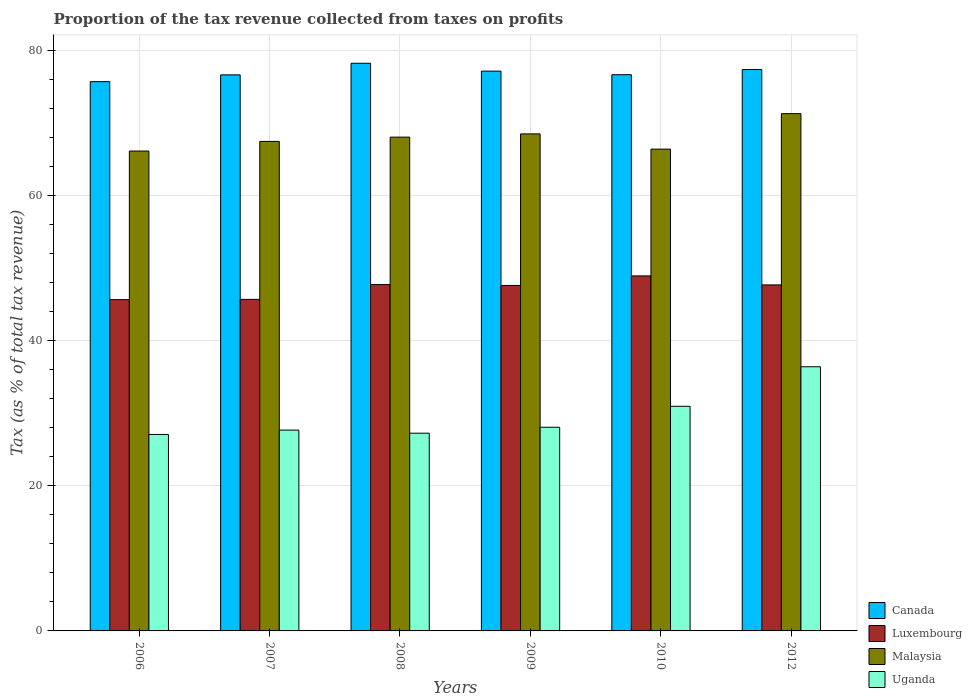How many different coloured bars are there?
Provide a succinct answer. 4. Are the number of bars per tick equal to the number of legend labels?
Your answer should be very brief. Yes. How many bars are there on the 3rd tick from the left?
Make the answer very short. 4. How many bars are there on the 4th tick from the right?
Make the answer very short. 4. In how many cases, is the number of bars for a given year not equal to the number of legend labels?
Provide a short and direct response. 0. What is the proportion of the tax revenue collected in Luxembourg in 2006?
Make the answer very short. 45.7. Across all years, what is the maximum proportion of the tax revenue collected in Canada?
Your answer should be very brief. 78.3. Across all years, what is the minimum proportion of the tax revenue collected in Canada?
Make the answer very short. 75.77. In which year was the proportion of the tax revenue collected in Luxembourg minimum?
Your response must be concise. 2006. What is the total proportion of the tax revenue collected in Malaysia in the graph?
Give a very brief answer. 408.21. What is the difference between the proportion of the tax revenue collected in Canada in 2007 and that in 2012?
Keep it short and to the point. -0.74. What is the difference between the proportion of the tax revenue collected in Uganda in 2007 and the proportion of the tax revenue collected in Canada in 2006?
Keep it short and to the point. -48.07. What is the average proportion of the tax revenue collected in Luxembourg per year?
Your response must be concise. 47.26. In the year 2009, what is the difference between the proportion of the tax revenue collected in Malaysia and proportion of the tax revenue collected in Uganda?
Your response must be concise. 40.47. What is the ratio of the proportion of the tax revenue collected in Luxembourg in 2008 to that in 2012?
Provide a short and direct response. 1. Is the proportion of the tax revenue collected in Canada in 2008 less than that in 2009?
Provide a short and direct response. No. Is the difference between the proportion of the tax revenue collected in Malaysia in 2007 and 2010 greater than the difference between the proportion of the tax revenue collected in Uganda in 2007 and 2010?
Provide a short and direct response. Yes. What is the difference between the highest and the second highest proportion of the tax revenue collected in Uganda?
Offer a very short reply. 5.46. What is the difference between the highest and the lowest proportion of the tax revenue collected in Canada?
Make the answer very short. 2.54. In how many years, is the proportion of the tax revenue collected in Uganda greater than the average proportion of the tax revenue collected in Uganda taken over all years?
Offer a terse response. 2. Is the sum of the proportion of the tax revenue collected in Canada in 2009 and 2010 greater than the maximum proportion of the tax revenue collected in Malaysia across all years?
Your answer should be very brief. Yes. What does the 2nd bar from the left in 2007 represents?
Provide a succinct answer. Luxembourg. Is it the case that in every year, the sum of the proportion of the tax revenue collected in Canada and proportion of the tax revenue collected in Luxembourg is greater than the proportion of the tax revenue collected in Malaysia?
Offer a terse response. Yes. Are all the bars in the graph horizontal?
Your answer should be very brief. No. How many legend labels are there?
Ensure brevity in your answer.  4. How are the legend labels stacked?
Give a very brief answer. Vertical. What is the title of the graph?
Your answer should be very brief. Proportion of the tax revenue collected from taxes on profits. What is the label or title of the Y-axis?
Offer a very short reply. Tax (as % of total tax revenue). What is the Tax (as % of total tax revenue) in Canada in 2006?
Ensure brevity in your answer.  75.77. What is the Tax (as % of total tax revenue) of Luxembourg in 2006?
Make the answer very short. 45.7. What is the Tax (as % of total tax revenue) in Malaysia in 2006?
Your answer should be very brief. 66.2. What is the Tax (as % of total tax revenue) in Uganda in 2006?
Your answer should be very brief. 27.1. What is the Tax (as % of total tax revenue) of Canada in 2007?
Offer a very short reply. 76.7. What is the Tax (as % of total tax revenue) in Luxembourg in 2007?
Your answer should be very brief. 45.74. What is the Tax (as % of total tax revenue) of Malaysia in 2007?
Make the answer very short. 67.53. What is the Tax (as % of total tax revenue) of Uganda in 2007?
Provide a succinct answer. 27.7. What is the Tax (as % of total tax revenue) in Canada in 2008?
Your response must be concise. 78.3. What is the Tax (as % of total tax revenue) of Luxembourg in 2008?
Provide a short and direct response. 47.78. What is the Tax (as % of total tax revenue) in Malaysia in 2008?
Your response must be concise. 68.11. What is the Tax (as % of total tax revenue) of Uganda in 2008?
Your answer should be very brief. 27.27. What is the Tax (as % of total tax revenue) in Canada in 2009?
Provide a short and direct response. 77.22. What is the Tax (as % of total tax revenue) in Luxembourg in 2009?
Your answer should be very brief. 47.66. What is the Tax (as % of total tax revenue) in Malaysia in 2009?
Offer a terse response. 68.56. What is the Tax (as % of total tax revenue) in Uganda in 2009?
Make the answer very short. 28.09. What is the Tax (as % of total tax revenue) in Canada in 2010?
Your response must be concise. 76.72. What is the Tax (as % of total tax revenue) of Luxembourg in 2010?
Provide a succinct answer. 48.97. What is the Tax (as % of total tax revenue) of Malaysia in 2010?
Your response must be concise. 66.46. What is the Tax (as % of total tax revenue) in Uganda in 2010?
Your answer should be very brief. 30.98. What is the Tax (as % of total tax revenue) of Canada in 2012?
Keep it short and to the point. 77.44. What is the Tax (as % of total tax revenue) in Luxembourg in 2012?
Provide a succinct answer. 47.73. What is the Tax (as % of total tax revenue) of Malaysia in 2012?
Ensure brevity in your answer.  71.35. What is the Tax (as % of total tax revenue) in Uganda in 2012?
Make the answer very short. 36.44. Across all years, what is the maximum Tax (as % of total tax revenue) in Canada?
Give a very brief answer. 78.3. Across all years, what is the maximum Tax (as % of total tax revenue) in Luxembourg?
Give a very brief answer. 48.97. Across all years, what is the maximum Tax (as % of total tax revenue) of Malaysia?
Ensure brevity in your answer.  71.35. Across all years, what is the maximum Tax (as % of total tax revenue) in Uganda?
Provide a succinct answer. 36.44. Across all years, what is the minimum Tax (as % of total tax revenue) in Canada?
Your response must be concise. 75.77. Across all years, what is the minimum Tax (as % of total tax revenue) of Luxembourg?
Your response must be concise. 45.7. Across all years, what is the minimum Tax (as % of total tax revenue) of Malaysia?
Make the answer very short. 66.2. Across all years, what is the minimum Tax (as % of total tax revenue) of Uganda?
Your answer should be compact. 27.1. What is the total Tax (as % of total tax revenue) in Canada in the graph?
Give a very brief answer. 462.16. What is the total Tax (as % of total tax revenue) in Luxembourg in the graph?
Your answer should be very brief. 283.57. What is the total Tax (as % of total tax revenue) of Malaysia in the graph?
Your answer should be very brief. 408.21. What is the total Tax (as % of total tax revenue) of Uganda in the graph?
Ensure brevity in your answer.  177.59. What is the difference between the Tax (as % of total tax revenue) in Canada in 2006 and that in 2007?
Your answer should be very brief. -0.94. What is the difference between the Tax (as % of total tax revenue) in Luxembourg in 2006 and that in 2007?
Offer a terse response. -0.03. What is the difference between the Tax (as % of total tax revenue) of Malaysia in 2006 and that in 2007?
Your answer should be compact. -1.33. What is the difference between the Tax (as % of total tax revenue) of Uganda in 2006 and that in 2007?
Ensure brevity in your answer.  -0.6. What is the difference between the Tax (as % of total tax revenue) in Canada in 2006 and that in 2008?
Your answer should be compact. -2.54. What is the difference between the Tax (as % of total tax revenue) of Luxembourg in 2006 and that in 2008?
Give a very brief answer. -2.08. What is the difference between the Tax (as % of total tax revenue) in Malaysia in 2006 and that in 2008?
Provide a short and direct response. -1.92. What is the difference between the Tax (as % of total tax revenue) of Uganda in 2006 and that in 2008?
Offer a terse response. -0.17. What is the difference between the Tax (as % of total tax revenue) in Canada in 2006 and that in 2009?
Your answer should be very brief. -1.45. What is the difference between the Tax (as % of total tax revenue) in Luxembourg in 2006 and that in 2009?
Keep it short and to the point. -1.95. What is the difference between the Tax (as % of total tax revenue) of Malaysia in 2006 and that in 2009?
Your answer should be very brief. -2.36. What is the difference between the Tax (as % of total tax revenue) in Uganda in 2006 and that in 2009?
Make the answer very short. -0.99. What is the difference between the Tax (as % of total tax revenue) of Canada in 2006 and that in 2010?
Ensure brevity in your answer.  -0.96. What is the difference between the Tax (as % of total tax revenue) in Luxembourg in 2006 and that in 2010?
Ensure brevity in your answer.  -3.27. What is the difference between the Tax (as % of total tax revenue) of Malaysia in 2006 and that in 2010?
Your answer should be compact. -0.26. What is the difference between the Tax (as % of total tax revenue) in Uganda in 2006 and that in 2010?
Your answer should be very brief. -3.88. What is the difference between the Tax (as % of total tax revenue) in Canada in 2006 and that in 2012?
Offer a very short reply. -1.67. What is the difference between the Tax (as % of total tax revenue) of Luxembourg in 2006 and that in 2012?
Provide a succinct answer. -2.03. What is the difference between the Tax (as % of total tax revenue) of Malaysia in 2006 and that in 2012?
Ensure brevity in your answer.  -5.15. What is the difference between the Tax (as % of total tax revenue) in Uganda in 2006 and that in 2012?
Your answer should be compact. -9.34. What is the difference between the Tax (as % of total tax revenue) in Canada in 2007 and that in 2008?
Your answer should be very brief. -1.6. What is the difference between the Tax (as % of total tax revenue) in Luxembourg in 2007 and that in 2008?
Your answer should be very brief. -2.04. What is the difference between the Tax (as % of total tax revenue) in Malaysia in 2007 and that in 2008?
Your answer should be compact. -0.59. What is the difference between the Tax (as % of total tax revenue) in Uganda in 2007 and that in 2008?
Offer a very short reply. 0.43. What is the difference between the Tax (as % of total tax revenue) in Canada in 2007 and that in 2009?
Your answer should be very brief. -0.52. What is the difference between the Tax (as % of total tax revenue) of Luxembourg in 2007 and that in 2009?
Give a very brief answer. -1.92. What is the difference between the Tax (as % of total tax revenue) in Malaysia in 2007 and that in 2009?
Ensure brevity in your answer.  -1.04. What is the difference between the Tax (as % of total tax revenue) of Uganda in 2007 and that in 2009?
Give a very brief answer. -0.39. What is the difference between the Tax (as % of total tax revenue) of Canada in 2007 and that in 2010?
Make the answer very short. -0.02. What is the difference between the Tax (as % of total tax revenue) in Luxembourg in 2007 and that in 2010?
Keep it short and to the point. -3.24. What is the difference between the Tax (as % of total tax revenue) of Malaysia in 2007 and that in 2010?
Ensure brevity in your answer.  1.07. What is the difference between the Tax (as % of total tax revenue) in Uganda in 2007 and that in 2010?
Make the answer very short. -3.28. What is the difference between the Tax (as % of total tax revenue) in Canada in 2007 and that in 2012?
Ensure brevity in your answer.  -0.74. What is the difference between the Tax (as % of total tax revenue) of Luxembourg in 2007 and that in 2012?
Your response must be concise. -2. What is the difference between the Tax (as % of total tax revenue) of Malaysia in 2007 and that in 2012?
Give a very brief answer. -3.83. What is the difference between the Tax (as % of total tax revenue) in Uganda in 2007 and that in 2012?
Make the answer very short. -8.74. What is the difference between the Tax (as % of total tax revenue) of Canada in 2008 and that in 2009?
Provide a succinct answer. 1.08. What is the difference between the Tax (as % of total tax revenue) of Luxembourg in 2008 and that in 2009?
Your answer should be compact. 0.12. What is the difference between the Tax (as % of total tax revenue) of Malaysia in 2008 and that in 2009?
Provide a succinct answer. -0.45. What is the difference between the Tax (as % of total tax revenue) in Uganda in 2008 and that in 2009?
Give a very brief answer. -0.82. What is the difference between the Tax (as % of total tax revenue) of Canada in 2008 and that in 2010?
Your answer should be compact. 1.58. What is the difference between the Tax (as % of total tax revenue) in Luxembourg in 2008 and that in 2010?
Provide a short and direct response. -1.19. What is the difference between the Tax (as % of total tax revenue) in Malaysia in 2008 and that in 2010?
Provide a succinct answer. 1.65. What is the difference between the Tax (as % of total tax revenue) of Uganda in 2008 and that in 2010?
Offer a terse response. -3.71. What is the difference between the Tax (as % of total tax revenue) in Canada in 2008 and that in 2012?
Offer a terse response. 0.86. What is the difference between the Tax (as % of total tax revenue) of Luxembourg in 2008 and that in 2012?
Offer a terse response. 0.05. What is the difference between the Tax (as % of total tax revenue) of Malaysia in 2008 and that in 2012?
Give a very brief answer. -3.24. What is the difference between the Tax (as % of total tax revenue) of Uganda in 2008 and that in 2012?
Your answer should be compact. -9.16. What is the difference between the Tax (as % of total tax revenue) in Canada in 2009 and that in 2010?
Offer a very short reply. 0.5. What is the difference between the Tax (as % of total tax revenue) in Luxembourg in 2009 and that in 2010?
Give a very brief answer. -1.32. What is the difference between the Tax (as % of total tax revenue) in Malaysia in 2009 and that in 2010?
Make the answer very short. 2.1. What is the difference between the Tax (as % of total tax revenue) of Uganda in 2009 and that in 2010?
Your answer should be compact. -2.89. What is the difference between the Tax (as % of total tax revenue) of Canada in 2009 and that in 2012?
Your answer should be compact. -0.22. What is the difference between the Tax (as % of total tax revenue) in Luxembourg in 2009 and that in 2012?
Provide a succinct answer. -0.08. What is the difference between the Tax (as % of total tax revenue) in Malaysia in 2009 and that in 2012?
Your answer should be very brief. -2.79. What is the difference between the Tax (as % of total tax revenue) in Uganda in 2009 and that in 2012?
Make the answer very short. -8.34. What is the difference between the Tax (as % of total tax revenue) of Canada in 2010 and that in 2012?
Your response must be concise. -0.72. What is the difference between the Tax (as % of total tax revenue) in Luxembourg in 2010 and that in 2012?
Provide a succinct answer. 1.24. What is the difference between the Tax (as % of total tax revenue) of Malaysia in 2010 and that in 2012?
Offer a terse response. -4.89. What is the difference between the Tax (as % of total tax revenue) in Uganda in 2010 and that in 2012?
Provide a succinct answer. -5.46. What is the difference between the Tax (as % of total tax revenue) in Canada in 2006 and the Tax (as % of total tax revenue) in Luxembourg in 2007?
Offer a terse response. 30.03. What is the difference between the Tax (as % of total tax revenue) of Canada in 2006 and the Tax (as % of total tax revenue) of Malaysia in 2007?
Make the answer very short. 8.24. What is the difference between the Tax (as % of total tax revenue) of Canada in 2006 and the Tax (as % of total tax revenue) of Uganda in 2007?
Give a very brief answer. 48.07. What is the difference between the Tax (as % of total tax revenue) of Luxembourg in 2006 and the Tax (as % of total tax revenue) of Malaysia in 2007?
Your answer should be very brief. -21.82. What is the difference between the Tax (as % of total tax revenue) of Luxembourg in 2006 and the Tax (as % of total tax revenue) of Uganda in 2007?
Your answer should be compact. 18. What is the difference between the Tax (as % of total tax revenue) in Malaysia in 2006 and the Tax (as % of total tax revenue) in Uganda in 2007?
Your answer should be very brief. 38.5. What is the difference between the Tax (as % of total tax revenue) of Canada in 2006 and the Tax (as % of total tax revenue) of Luxembourg in 2008?
Your response must be concise. 27.99. What is the difference between the Tax (as % of total tax revenue) of Canada in 2006 and the Tax (as % of total tax revenue) of Malaysia in 2008?
Provide a succinct answer. 7.66. What is the difference between the Tax (as % of total tax revenue) of Canada in 2006 and the Tax (as % of total tax revenue) of Uganda in 2008?
Give a very brief answer. 48.49. What is the difference between the Tax (as % of total tax revenue) of Luxembourg in 2006 and the Tax (as % of total tax revenue) of Malaysia in 2008?
Provide a succinct answer. -22.41. What is the difference between the Tax (as % of total tax revenue) of Luxembourg in 2006 and the Tax (as % of total tax revenue) of Uganda in 2008?
Your answer should be very brief. 18.43. What is the difference between the Tax (as % of total tax revenue) in Malaysia in 2006 and the Tax (as % of total tax revenue) in Uganda in 2008?
Your answer should be compact. 38.92. What is the difference between the Tax (as % of total tax revenue) of Canada in 2006 and the Tax (as % of total tax revenue) of Luxembourg in 2009?
Provide a short and direct response. 28.11. What is the difference between the Tax (as % of total tax revenue) of Canada in 2006 and the Tax (as % of total tax revenue) of Malaysia in 2009?
Make the answer very short. 7.21. What is the difference between the Tax (as % of total tax revenue) of Canada in 2006 and the Tax (as % of total tax revenue) of Uganda in 2009?
Ensure brevity in your answer.  47.67. What is the difference between the Tax (as % of total tax revenue) in Luxembourg in 2006 and the Tax (as % of total tax revenue) in Malaysia in 2009?
Keep it short and to the point. -22.86. What is the difference between the Tax (as % of total tax revenue) of Luxembourg in 2006 and the Tax (as % of total tax revenue) of Uganda in 2009?
Provide a succinct answer. 17.61. What is the difference between the Tax (as % of total tax revenue) of Malaysia in 2006 and the Tax (as % of total tax revenue) of Uganda in 2009?
Provide a succinct answer. 38.1. What is the difference between the Tax (as % of total tax revenue) in Canada in 2006 and the Tax (as % of total tax revenue) in Luxembourg in 2010?
Offer a very short reply. 26.8. What is the difference between the Tax (as % of total tax revenue) in Canada in 2006 and the Tax (as % of total tax revenue) in Malaysia in 2010?
Give a very brief answer. 9.31. What is the difference between the Tax (as % of total tax revenue) of Canada in 2006 and the Tax (as % of total tax revenue) of Uganda in 2010?
Offer a terse response. 44.78. What is the difference between the Tax (as % of total tax revenue) of Luxembourg in 2006 and the Tax (as % of total tax revenue) of Malaysia in 2010?
Give a very brief answer. -20.76. What is the difference between the Tax (as % of total tax revenue) of Luxembourg in 2006 and the Tax (as % of total tax revenue) of Uganda in 2010?
Offer a very short reply. 14.72. What is the difference between the Tax (as % of total tax revenue) of Malaysia in 2006 and the Tax (as % of total tax revenue) of Uganda in 2010?
Offer a very short reply. 35.21. What is the difference between the Tax (as % of total tax revenue) of Canada in 2006 and the Tax (as % of total tax revenue) of Luxembourg in 2012?
Offer a very short reply. 28.04. What is the difference between the Tax (as % of total tax revenue) in Canada in 2006 and the Tax (as % of total tax revenue) in Malaysia in 2012?
Offer a terse response. 4.42. What is the difference between the Tax (as % of total tax revenue) in Canada in 2006 and the Tax (as % of total tax revenue) in Uganda in 2012?
Your answer should be compact. 39.33. What is the difference between the Tax (as % of total tax revenue) of Luxembourg in 2006 and the Tax (as % of total tax revenue) of Malaysia in 2012?
Provide a short and direct response. -25.65. What is the difference between the Tax (as % of total tax revenue) in Luxembourg in 2006 and the Tax (as % of total tax revenue) in Uganda in 2012?
Offer a very short reply. 9.26. What is the difference between the Tax (as % of total tax revenue) in Malaysia in 2006 and the Tax (as % of total tax revenue) in Uganda in 2012?
Offer a terse response. 29.76. What is the difference between the Tax (as % of total tax revenue) in Canada in 2007 and the Tax (as % of total tax revenue) in Luxembourg in 2008?
Keep it short and to the point. 28.93. What is the difference between the Tax (as % of total tax revenue) in Canada in 2007 and the Tax (as % of total tax revenue) in Malaysia in 2008?
Keep it short and to the point. 8.59. What is the difference between the Tax (as % of total tax revenue) of Canada in 2007 and the Tax (as % of total tax revenue) of Uganda in 2008?
Give a very brief answer. 49.43. What is the difference between the Tax (as % of total tax revenue) of Luxembourg in 2007 and the Tax (as % of total tax revenue) of Malaysia in 2008?
Keep it short and to the point. -22.38. What is the difference between the Tax (as % of total tax revenue) of Luxembourg in 2007 and the Tax (as % of total tax revenue) of Uganda in 2008?
Make the answer very short. 18.46. What is the difference between the Tax (as % of total tax revenue) in Malaysia in 2007 and the Tax (as % of total tax revenue) in Uganda in 2008?
Offer a terse response. 40.25. What is the difference between the Tax (as % of total tax revenue) in Canada in 2007 and the Tax (as % of total tax revenue) in Luxembourg in 2009?
Provide a short and direct response. 29.05. What is the difference between the Tax (as % of total tax revenue) of Canada in 2007 and the Tax (as % of total tax revenue) of Malaysia in 2009?
Provide a succinct answer. 8.14. What is the difference between the Tax (as % of total tax revenue) in Canada in 2007 and the Tax (as % of total tax revenue) in Uganda in 2009?
Offer a terse response. 48.61. What is the difference between the Tax (as % of total tax revenue) in Luxembourg in 2007 and the Tax (as % of total tax revenue) in Malaysia in 2009?
Provide a succinct answer. -22.83. What is the difference between the Tax (as % of total tax revenue) of Luxembourg in 2007 and the Tax (as % of total tax revenue) of Uganda in 2009?
Your answer should be compact. 17.64. What is the difference between the Tax (as % of total tax revenue) of Malaysia in 2007 and the Tax (as % of total tax revenue) of Uganda in 2009?
Keep it short and to the point. 39.43. What is the difference between the Tax (as % of total tax revenue) of Canada in 2007 and the Tax (as % of total tax revenue) of Luxembourg in 2010?
Make the answer very short. 27.73. What is the difference between the Tax (as % of total tax revenue) of Canada in 2007 and the Tax (as % of total tax revenue) of Malaysia in 2010?
Provide a short and direct response. 10.24. What is the difference between the Tax (as % of total tax revenue) of Canada in 2007 and the Tax (as % of total tax revenue) of Uganda in 2010?
Your answer should be very brief. 45.72. What is the difference between the Tax (as % of total tax revenue) of Luxembourg in 2007 and the Tax (as % of total tax revenue) of Malaysia in 2010?
Ensure brevity in your answer.  -20.72. What is the difference between the Tax (as % of total tax revenue) in Luxembourg in 2007 and the Tax (as % of total tax revenue) in Uganda in 2010?
Your answer should be very brief. 14.75. What is the difference between the Tax (as % of total tax revenue) in Malaysia in 2007 and the Tax (as % of total tax revenue) in Uganda in 2010?
Offer a terse response. 36.54. What is the difference between the Tax (as % of total tax revenue) in Canada in 2007 and the Tax (as % of total tax revenue) in Luxembourg in 2012?
Give a very brief answer. 28.97. What is the difference between the Tax (as % of total tax revenue) of Canada in 2007 and the Tax (as % of total tax revenue) of Malaysia in 2012?
Offer a very short reply. 5.35. What is the difference between the Tax (as % of total tax revenue) in Canada in 2007 and the Tax (as % of total tax revenue) in Uganda in 2012?
Offer a terse response. 40.27. What is the difference between the Tax (as % of total tax revenue) in Luxembourg in 2007 and the Tax (as % of total tax revenue) in Malaysia in 2012?
Offer a terse response. -25.62. What is the difference between the Tax (as % of total tax revenue) in Luxembourg in 2007 and the Tax (as % of total tax revenue) in Uganda in 2012?
Offer a terse response. 9.3. What is the difference between the Tax (as % of total tax revenue) of Malaysia in 2007 and the Tax (as % of total tax revenue) of Uganda in 2012?
Offer a terse response. 31.09. What is the difference between the Tax (as % of total tax revenue) in Canada in 2008 and the Tax (as % of total tax revenue) in Luxembourg in 2009?
Provide a succinct answer. 30.65. What is the difference between the Tax (as % of total tax revenue) in Canada in 2008 and the Tax (as % of total tax revenue) in Malaysia in 2009?
Your response must be concise. 9.74. What is the difference between the Tax (as % of total tax revenue) of Canada in 2008 and the Tax (as % of total tax revenue) of Uganda in 2009?
Keep it short and to the point. 50.21. What is the difference between the Tax (as % of total tax revenue) of Luxembourg in 2008 and the Tax (as % of total tax revenue) of Malaysia in 2009?
Ensure brevity in your answer.  -20.78. What is the difference between the Tax (as % of total tax revenue) in Luxembourg in 2008 and the Tax (as % of total tax revenue) in Uganda in 2009?
Offer a very short reply. 19.68. What is the difference between the Tax (as % of total tax revenue) in Malaysia in 2008 and the Tax (as % of total tax revenue) in Uganda in 2009?
Offer a very short reply. 40.02. What is the difference between the Tax (as % of total tax revenue) in Canada in 2008 and the Tax (as % of total tax revenue) in Luxembourg in 2010?
Give a very brief answer. 29.33. What is the difference between the Tax (as % of total tax revenue) of Canada in 2008 and the Tax (as % of total tax revenue) of Malaysia in 2010?
Give a very brief answer. 11.84. What is the difference between the Tax (as % of total tax revenue) of Canada in 2008 and the Tax (as % of total tax revenue) of Uganda in 2010?
Your answer should be very brief. 47.32. What is the difference between the Tax (as % of total tax revenue) of Luxembourg in 2008 and the Tax (as % of total tax revenue) of Malaysia in 2010?
Give a very brief answer. -18.68. What is the difference between the Tax (as % of total tax revenue) in Luxembourg in 2008 and the Tax (as % of total tax revenue) in Uganda in 2010?
Keep it short and to the point. 16.8. What is the difference between the Tax (as % of total tax revenue) of Malaysia in 2008 and the Tax (as % of total tax revenue) of Uganda in 2010?
Offer a very short reply. 37.13. What is the difference between the Tax (as % of total tax revenue) of Canada in 2008 and the Tax (as % of total tax revenue) of Luxembourg in 2012?
Your response must be concise. 30.57. What is the difference between the Tax (as % of total tax revenue) in Canada in 2008 and the Tax (as % of total tax revenue) in Malaysia in 2012?
Your answer should be very brief. 6.95. What is the difference between the Tax (as % of total tax revenue) of Canada in 2008 and the Tax (as % of total tax revenue) of Uganda in 2012?
Your answer should be compact. 41.87. What is the difference between the Tax (as % of total tax revenue) in Luxembourg in 2008 and the Tax (as % of total tax revenue) in Malaysia in 2012?
Your answer should be very brief. -23.57. What is the difference between the Tax (as % of total tax revenue) in Luxembourg in 2008 and the Tax (as % of total tax revenue) in Uganda in 2012?
Provide a short and direct response. 11.34. What is the difference between the Tax (as % of total tax revenue) in Malaysia in 2008 and the Tax (as % of total tax revenue) in Uganda in 2012?
Your answer should be compact. 31.67. What is the difference between the Tax (as % of total tax revenue) in Canada in 2009 and the Tax (as % of total tax revenue) in Luxembourg in 2010?
Provide a short and direct response. 28.25. What is the difference between the Tax (as % of total tax revenue) of Canada in 2009 and the Tax (as % of total tax revenue) of Malaysia in 2010?
Give a very brief answer. 10.76. What is the difference between the Tax (as % of total tax revenue) of Canada in 2009 and the Tax (as % of total tax revenue) of Uganda in 2010?
Provide a succinct answer. 46.24. What is the difference between the Tax (as % of total tax revenue) of Luxembourg in 2009 and the Tax (as % of total tax revenue) of Malaysia in 2010?
Provide a succinct answer. -18.8. What is the difference between the Tax (as % of total tax revenue) of Luxembourg in 2009 and the Tax (as % of total tax revenue) of Uganda in 2010?
Provide a succinct answer. 16.67. What is the difference between the Tax (as % of total tax revenue) of Malaysia in 2009 and the Tax (as % of total tax revenue) of Uganda in 2010?
Keep it short and to the point. 37.58. What is the difference between the Tax (as % of total tax revenue) in Canada in 2009 and the Tax (as % of total tax revenue) in Luxembourg in 2012?
Make the answer very short. 29.49. What is the difference between the Tax (as % of total tax revenue) of Canada in 2009 and the Tax (as % of total tax revenue) of Malaysia in 2012?
Provide a succinct answer. 5.87. What is the difference between the Tax (as % of total tax revenue) of Canada in 2009 and the Tax (as % of total tax revenue) of Uganda in 2012?
Ensure brevity in your answer.  40.78. What is the difference between the Tax (as % of total tax revenue) of Luxembourg in 2009 and the Tax (as % of total tax revenue) of Malaysia in 2012?
Give a very brief answer. -23.7. What is the difference between the Tax (as % of total tax revenue) of Luxembourg in 2009 and the Tax (as % of total tax revenue) of Uganda in 2012?
Your answer should be compact. 11.22. What is the difference between the Tax (as % of total tax revenue) of Malaysia in 2009 and the Tax (as % of total tax revenue) of Uganda in 2012?
Your response must be concise. 32.12. What is the difference between the Tax (as % of total tax revenue) in Canada in 2010 and the Tax (as % of total tax revenue) in Luxembourg in 2012?
Your answer should be compact. 28.99. What is the difference between the Tax (as % of total tax revenue) of Canada in 2010 and the Tax (as % of total tax revenue) of Malaysia in 2012?
Your answer should be very brief. 5.37. What is the difference between the Tax (as % of total tax revenue) in Canada in 2010 and the Tax (as % of total tax revenue) in Uganda in 2012?
Offer a terse response. 40.29. What is the difference between the Tax (as % of total tax revenue) in Luxembourg in 2010 and the Tax (as % of total tax revenue) in Malaysia in 2012?
Your answer should be compact. -22.38. What is the difference between the Tax (as % of total tax revenue) of Luxembourg in 2010 and the Tax (as % of total tax revenue) of Uganda in 2012?
Offer a terse response. 12.53. What is the difference between the Tax (as % of total tax revenue) in Malaysia in 2010 and the Tax (as % of total tax revenue) in Uganda in 2012?
Offer a very short reply. 30.02. What is the average Tax (as % of total tax revenue) of Canada per year?
Keep it short and to the point. 77.03. What is the average Tax (as % of total tax revenue) in Luxembourg per year?
Your answer should be compact. 47.26. What is the average Tax (as % of total tax revenue) of Malaysia per year?
Keep it short and to the point. 68.03. What is the average Tax (as % of total tax revenue) in Uganda per year?
Give a very brief answer. 29.6. In the year 2006, what is the difference between the Tax (as % of total tax revenue) in Canada and Tax (as % of total tax revenue) in Luxembourg?
Your answer should be very brief. 30.07. In the year 2006, what is the difference between the Tax (as % of total tax revenue) of Canada and Tax (as % of total tax revenue) of Malaysia?
Offer a terse response. 9.57. In the year 2006, what is the difference between the Tax (as % of total tax revenue) in Canada and Tax (as % of total tax revenue) in Uganda?
Offer a very short reply. 48.67. In the year 2006, what is the difference between the Tax (as % of total tax revenue) of Luxembourg and Tax (as % of total tax revenue) of Malaysia?
Your answer should be compact. -20.5. In the year 2006, what is the difference between the Tax (as % of total tax revenue) of Luxembourg and Tax (as % of total tax revenue) of Uganda?
Provide a short and direct response. 18.6. In the year 2006, what is the difference between the Tax (as % of total tax revenue) in Malaysia and Tax (as % of total tax revenue) in Uganda?
Provide a short and direct response. 39.1. In the year 2007, what is the difference between the Tax (as % of total tax revenue) in Canada and Tax (as % of total tax revenue) in Luxembourg?
Your answer should be compact. 30.97. In the year 2007, what is the difference between the Tax (as % of total tax revenue) in Canada and Tax (as % of total tax revenue) in Malaysia?
Your answer should be compact. 9.18. In the year 2007, what is the difference between the Tax (as % of total tax revenue) of Canada and Tax (as % of total tax revenue) of Uganda?
Your response must be concise. 49. In the year 2007, what is the difference between the Tax (as % of total tax revenue) in Luxembourg and Tax (as % of total tax revenue) in Malaysia?
Keep it short and to the point. -21.79. In the year 2007, what is the difference between the Tax (as % of total tax revenue) in Luxembourg and Tax (as % of total tax revenue) in Uganda?
Your answer should be compact. 18.03. In the year 2007, what is the difference between the Tax (as % of total tax revenue) of Malaysia and Tax (as % of total tax revenue) of Uganda?
Ensure brevity in your answer.  39.82. In the year 2008, what is the difference between the Tax (as % of total tax revenue) of Canada and Tax (as % of total tax revenue) of Luxembourg?
Ensure brevity in your answer.  30.53. In the year 2008, what is the difference between the Tax (as % of total tax revenue) in Canada and Tax (as % of total tax revenue) in Malaysia?
Provide a succinct answer. 10.19. In the year 2008, what is the difference between the Tax (as % of total tax revenue) of Canada and Tax (as % of total tax revenue) of Uganda?
Offer a terse response. 51.03. In the year 2008, what is the difference between the Tax (as % of total tax revenue) of Luxembourg and Tax (as % of total tax revenue) of Malaysia?
Your response must be concise. -20.33. In the year 2008, what is the difference between the Tax (as % of total tax revenue) in Luxembourg and Tax (as % of total tax revenue) in Uganda?
Give a very brief answer. 20.51. In the year 2008, what is the difference between the Tax (as % of total tax revenue) of Malaysia and Tax (as % of total tax revenue) of Uganda?
Your response must be concise. 40.84. In the year 2009, what is the difference between the Tax (as % of total tax revenue) of Canada and Tax (as % of total tax revenue) of Luxembourg?
Offer a terse response. 29.57. In the year 2009, what is the difference between the Tax (as % of total tax revenue) in Canada and Tax (as % of total tax revenue) in Malaysia?
Your answer should be very brief. 8.66. In the year 2009, what is the difference between the Tax (as % of total tax revenue) in Canada and Tax (as % of total tax revenue) in Uganda?
Provide a short and direct response. 49.13. In the year 2009, what is the difference between the Tax (as % of total tax revenue) of Luxembourg and Tax (as % of total tax revenue) of Malaysia?
Keep it short and to the point. -20.91. In the year 2009, what is the difference between the Tax (as % of total tax revenue) of Luxembourg and Tax (as % of total tax revenue) of Uganda?
Ensure brevity in your answer.  19.56. In the year 2009, what is the difference between the Tax (as % of total tax revenue) in Malaysia and Tax (as % of total tax revenue) in Uganda?
Ensure brevity in your answer.  40.47. In the year 2010, what is the difference between the Tax (as % of total tax revenue) of Canada and Tax (as % of total tax revenue) of Luxembourg?
Your answer should be compact. 27.75. In the year 2010, what is the difference between the Tax (as % of total tax revenue) in Canada and Tax (as % of total tax revenue) in Malaysia?
Make the answer very short. 10.26. In the year 2010, what is the difference between the Tax (as % of total tax revenue) of Canada and Tax (as % of total tax revenue) of Uganda?
Offer a terse response. 45.74. In the year 2010, what is the difference between the Tax (as % of total tax revenue) in Luxembourg and Tax (as % of total tax revenue) in Malaysia?
Your answer should be compact. -17.49. In the year 2010, what is the difference between the Tax (as % of total tax revenue) in Luxembourg and Tax (as % of total tax revenue) in Uganda?
Provide a short and direct response. 17.99. In the year 2010, what is the difference between the Tax (as % of total tax revenue) of Malaysia and Tax (as % of total tax revenue) of Uganda?
Make the answer very short. 35.48. In the year 2012, what is the difference between the Tax (as % of total tax revenue) of Canada and Tax (as % of total tax revenue) of Luxembourg?
Provide a short and direct response. 29.71. In the year 2012, what is the difference between the Tax (as % of total tax revenue) in Canada and Tax (as % of total tax revenue) in Malaysia?
Make the answer very short. 6.09. In the year 2012, what is the difference between the Tax (as % of total tax revenue) in Canada and Tax (as % of total tax revenue) in Uganda?
Keep it short and to the point. 41. In the year 2012, what is the difference between the Tax (as % of total tax revenue) in Luxembourg and Tax (as % of total tax revenue) in Malaysia?
Offer a very short reply. -23.62. In the year 2012, what is the difference between the Tax (as % of total tax revenue) of Luxembourg and Tax (as % of total tax revenue) of Uganda?
Offer a terse response. 11.29. In the year 2012, what is the difference between the Tax (as % of total tax revenue) in Malaysia and Tax (as % of total tax revenue) in Uganda?
Offer a terse response. 34.91. What is the ratio of the Tax (as % of total tax revenue) of Canada in 2006 to that in 2007?
Your response must be concise. 0.99. What is the ratio of the Tax (as % of total tax revenue) of Luxembourg in 2006 to that in 2007?
Your answer should be compact. 1. What is the ratio of the Tax (as % of total tax revenue) of Malaysia in 2006 to that in 2007?
Provide a succinct answer. 0.98. What is the ratio of the Tax (as % of total tax revenue) of Uganda in 2006 to that in 2007?
Your response must be concise. 0.98. What is the ratio of the Tax (as % of total tax revenue) in Canada in 2006 to that in 2008?
Ensure brevity in your answer.  0.97. What is the ratio of the Tax (as % of total tax revenue) in Luxembourg in 2006 to that in 2008?
Provide a short and direct response. 0.96. What is the ratio of the Tax (as % of total tax revenue) in Malaysia in 2006 to that in 2008?
Offer a very short reply. 0.97. What is the ratio of the Tax (as % of total tax revenue) of Uganda in 2006 to that in 2008?
Your answer should be very brief. 0.99. What is the ratio of the Tax (as % of total tax revenue) of Canada in 2006 to that in 2009?
Provide a succinct answer. 0.98. What is the ratio of the Tax (as % of total tax revenue) in Malaysia in 2006 to that in 2009?
Make the answer very short. 0.97. What is the ratio of the Tax (as % of total tax revenue) of Uganda in 2006 to that in 2009?
Your response must be concise. 0.96. What is the ratio of the Tax (as % of total tax revenue) in Canada in 2006 to that in 2010?
Provide a succinct answer. 0.99. What is the ratio of the Tax (as % of total tax revenue) in Luxembourg in 2006 to that in 2010?
Keep it short and to the point. 0.93. What is the ratio of the Tax (as % of total tax revenue) of Malaysia in 2006 to that in 2010?
Offer a very short reply. 1. What is the ratio of the Tax (as % of total tax revenue) of Uganda in 2006 to that in 2010?
Provide a short and direct response. 0.87. What is the ratio of the Tax (as % of total tax revenue) of Canada in 2006 to that in 2012?
Keep it short and to the point. 0.98. What is the ratio of the Tax (as % of total tax revenue) of Luxembourg in 2006 to that in 2012?
Provide a short and direct response. 0.96. What is the ratio of the Tax (as % of total tax revenue) in Malaysia in 2006 to that in 2012?
Ensure brevity in your answer.  0.93. What is the ratio of the Tax (as % of total tax revenue) of Uganda in 2006 to that in 2012?
Your answer should be very brief. 0.74. What is the ratio of the Tax (as % of total tax revenue) of Canada in 2007 to that in 2008?
Offer a very short reply. 0.98. What is the ratio of the Tax (as % of total tax revenue) of Luxembourg in 2007 to that in 2008?
Your answer should be very brief. 0.96. What is the ratio of the Tax (as % of total tax revenue) in Uganda in 2007 to that in 2008?
Offer a very short reply. 1.02. What is the ratio of the Tax (as % of total tax revenue) of Luxembourg in 2007 to that in 2009?
Your answer should be compact. 0.96. What is the ratio of the Tax (as % of total tax revenue) in Malaysia in 2007 to that in 2009?
Offer a terse response. 0.98. What is the ratio of the Tax (as % of total tax revenue) in Uganda in 2007 to that in 2009?
Your answer should be compact. 0.99. What is the ratio of the Tax (as % of total tax revenue) of Canada in 2007 to that in 2010?
Offer a terse response. 1. What is the ratio of the Tax (as % of total tax revenue) in Luxembourg in 2007 to that in 2010?
Keep it short and to the point. 0.93. What is the ratio of the Tax (as % of total tax revenue) in Malaysia in 2007 to that in 2010?
Your answer should be very brief. 1.02. What is the ratio of the Tax (as % of total tax revenue) of Uganda in 2007 to that in 2010?
Offer a terse response. 0.89. What is the ratio of the Tax (as % of total tax revenue) in Canada in 2007 to that in 2012?
Provide a succinct answer. 0.99. What is the ratio of the Tax (as % of total tax revenue) in Luxembourg in 2007 to that in 2012?
Provide a succinct answer. 0.96. What is the ratio of the Tax (as % of total tax revenue) of Malaysia in 2007 to that in 2012?
Offer a terse response. 0.95. What is the ratio of the Tax (as % of total tax revenue) in Uganda in 2007 to that in 2012?
Keep it short and to the point. 0.76. What is the ratio of the Tax (as % of total tax revenue) of Uganda in 2008 to that in 2009?
Offer a very short reply. 0.97. What is the ratio of the Tax (as % of total tax revenue) in Canada in 2008 to that in 2010?
Your answer should be very brief. 1.02. What is the ratio of the Tax (as % of total tax revenue) of Luxembourg in 2008 to that in 2010?
Make the answer very short. 0.98. What is the ratio of the Tax (as % of total tax revenue) of Malaysia in 2008 to that in 2010?
Make the answer very short. 1.02. What is the ratio of the Tax (as % of total tax revenue) in Uganda in 2008 to that in 2010?
Offer a very short reply. 0.88. What is the ratio of the Tax (as % of total tax revenue) of Canada in 2008 to that in 2012?
Make the answer very short. 1.01. What is the ratio of the Tax (as % of total tax revenue) of Luxembourg in 2008 to that in 2012?
Provide a succinct answer. 1. What is the ratio of the Tax (as % of total tax revenue) of Malaysia in 2008 to that in 2012?
Your response must be concise. 0.95. What is the ratio of the Tax (as % of total tax revenue) in Uganda in 2008 to that in 2012?
Keep it short and to the point. 0.75. What is the ratio of the Tax (as % of total tax revenue) of Luxembourg in 2009 to that in 2010?
Offer a very short reply. 0.97. What is the ratio of the Tax (as % of total tax revenue) in Malaysia in 2009 to that in 2010?
Provide a short and direct response. 1.03. What is the ratio of the Tax (as % of total tax revenue) of Uganda in 2009 to that in 2010?
Provide a short and direct response. 0.91. What is the ratio of the Tax (as % of total tax revenue) of Malaysia in 2009 to that in 2012?
Keep it short and to the point. 0.96. What is the ratio of the Tax (as % of total tax revenue) in Uganda in 2009 to that in 2012?
Offer a terse response. 0.77. What is the ratio of the Tax (as % of total tax revenue) of Luxembourg in 2010 to that in 2012?
Give a very brief answer. 1.03. What is the ratio of the Tax (as % of total tax revenue) of Malaysia in 2010 to that in 2012?
Provide a succinct answer. 0.93. What is the ratio of the Tax (as % of total tax revenue) of Uganda in 2010 to that in 2012?
Provide a succinct answer. 0.85. What is the difference between the highest and the second highest Tax (as % of total tax revenue) of Canada?
Your answer should be very brief. 0.86. What is the difference between the highest and the second highest Tax (as % of total tax revenue) of Luxembourg?
Give a very brief answer. 1.19. What is the difference between the highest and the second highest Tax (as % of total tax revenue) of Malaysia?
Keep it short and to the point. 2.79. What is the difference between the highest and the second highest Tax (as % of total tax revenue) of Uganda?
Your response must be concise. 5.46. What is the difference between the highest and the lowest Tax (as % of total tax revenue) in Canada?
Provide a succinct answer. 2.54. What is the difference between the highest and the lowest Tax (as % of total tax revenue) of Luxembourg?
Ensure brevity in your answer.  3.27. What is the difference between the highest and the lowest Tax (as % of total tax revenue) of Malaysia?
Your answer should be very brief. 5.15. What is the difference between the highest and the lowest Tax (as % of total tax revenue) in Uganda?
Give a very brief answer. 9.34. 